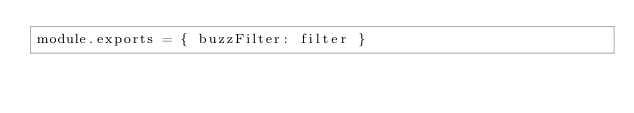<code> <loc_0><loc_0><loc_500><loc_500><_JavaScript_>module.exports = { buzzFilter: filter }
</code> 